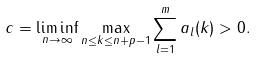Convert formula to latex. <formula><loc_0><loc_0><loc_500><loc_500>c = \liminf _ { n \to \infty } \max _ { n \leq k \leq n + p - 1 } \sum _ { l = 1 } ^ { m } a _ { l } ( k ) > 0 .</formula> 